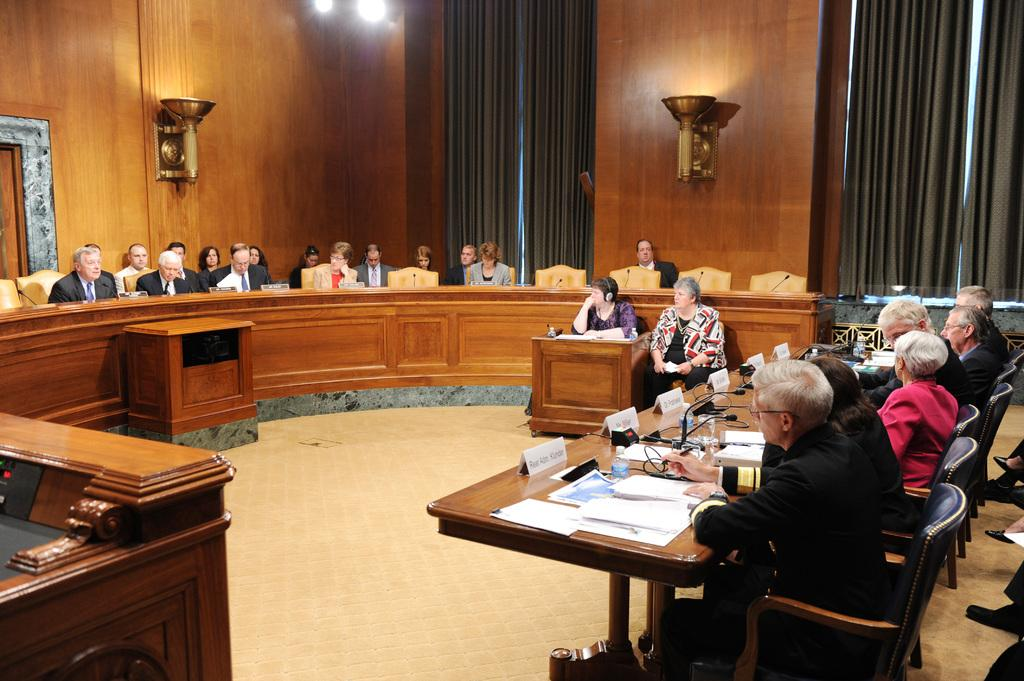What are the people in the image doing? The people in the image are sitting on chairs. What is on the table in the image? There are mice and papers on the table in the image. What can be seen in the background of the image? There are curtains and lights in the background of the image. Can you see the ocean in the image? No, there is no ocean present in the image. What color is the crayon used to draw on the papers in the image? There are no crayons or drawings on the papers in the image. 